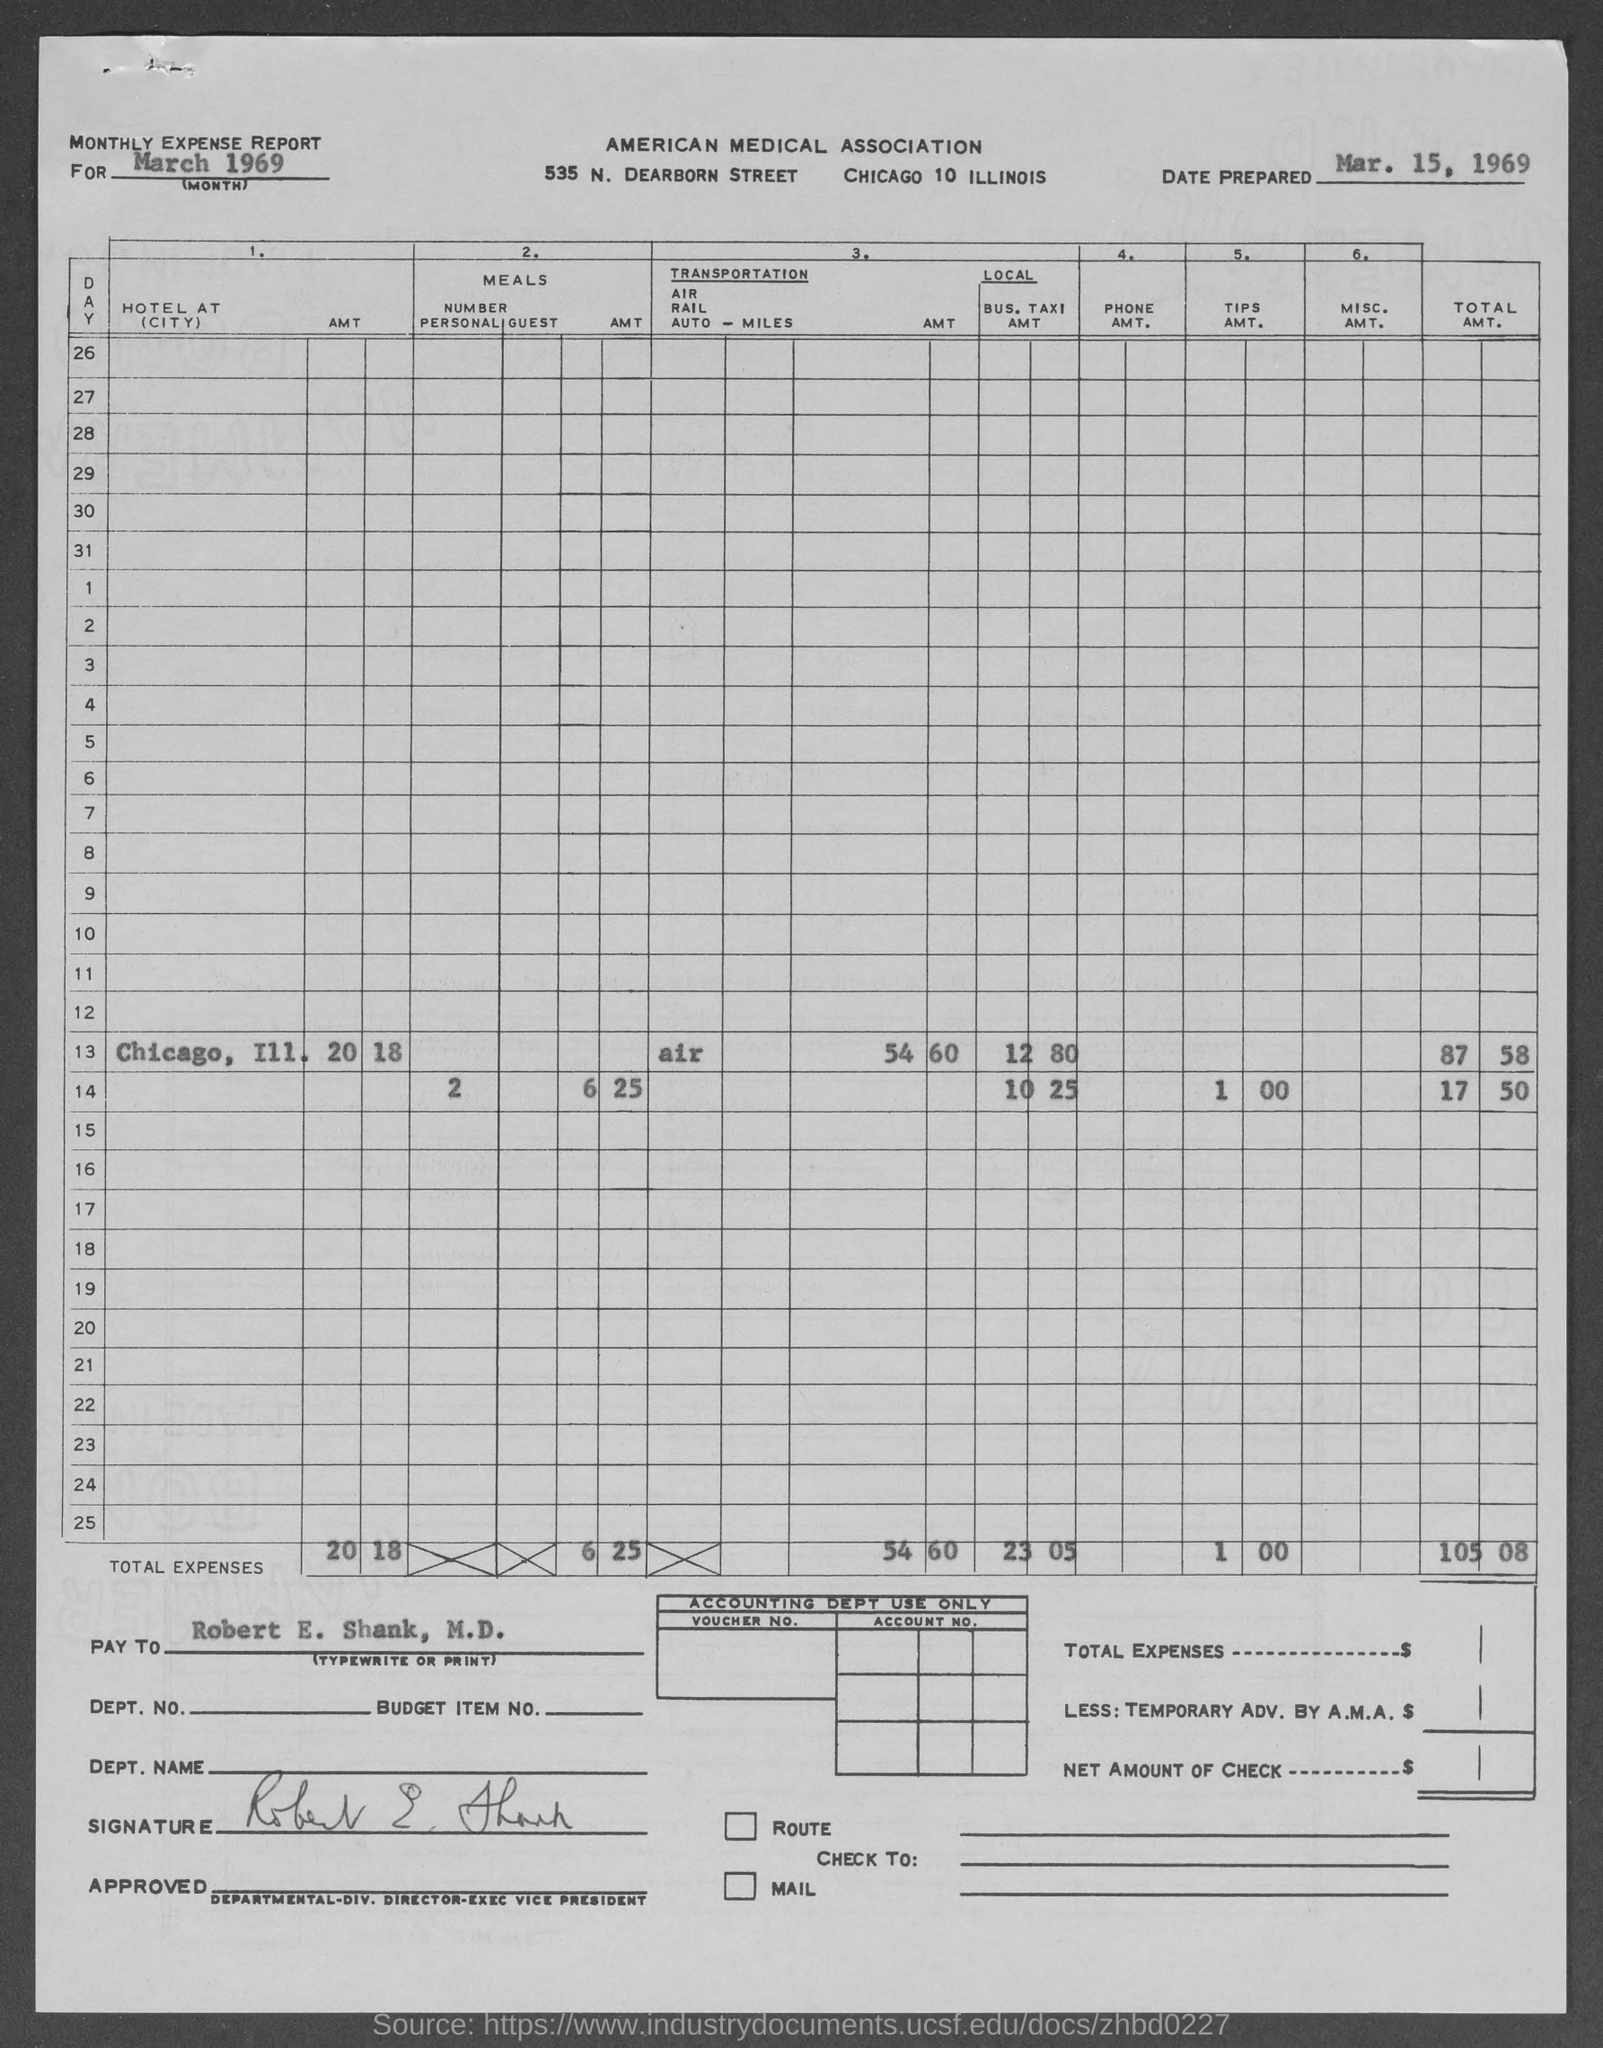List a handful of essential elements in this visual. The date prepared as per the document is March 15, 1969. 